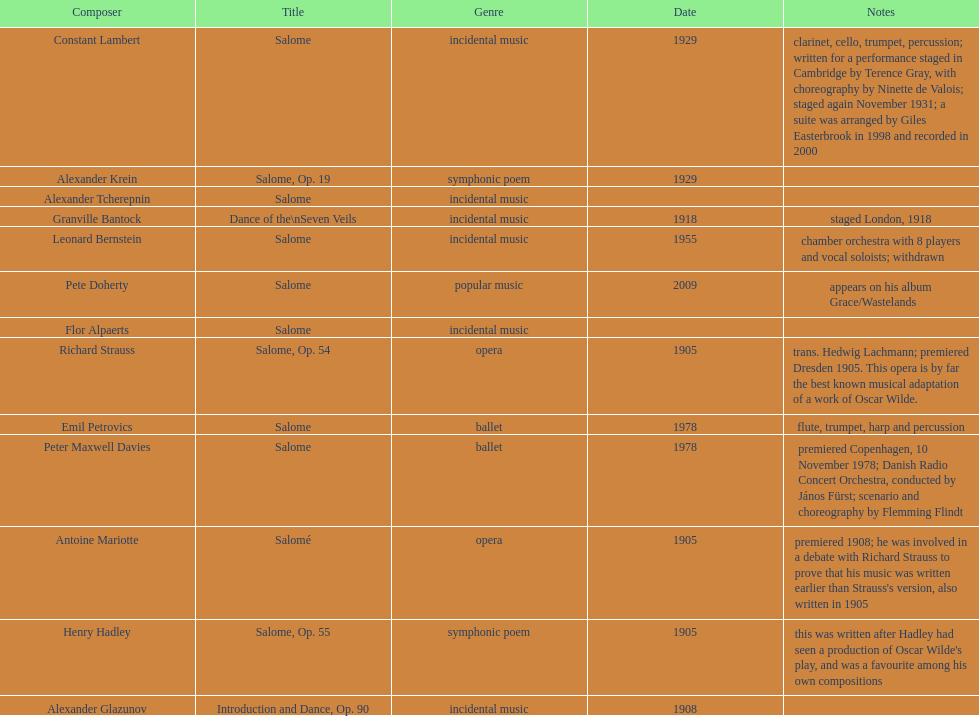Which composer published first granville bantock or emil petrovics? Granville Bantock. 